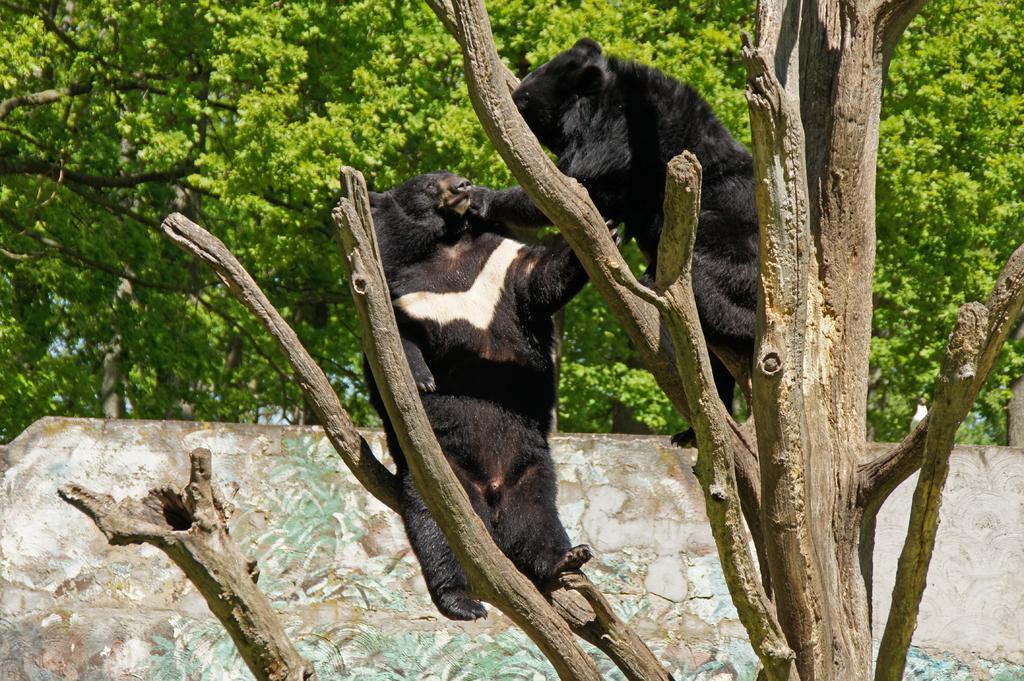Can you describe this image briefly? In this image we can see animals on a tree. Behind the animals we can see a wall and a group of trees. 